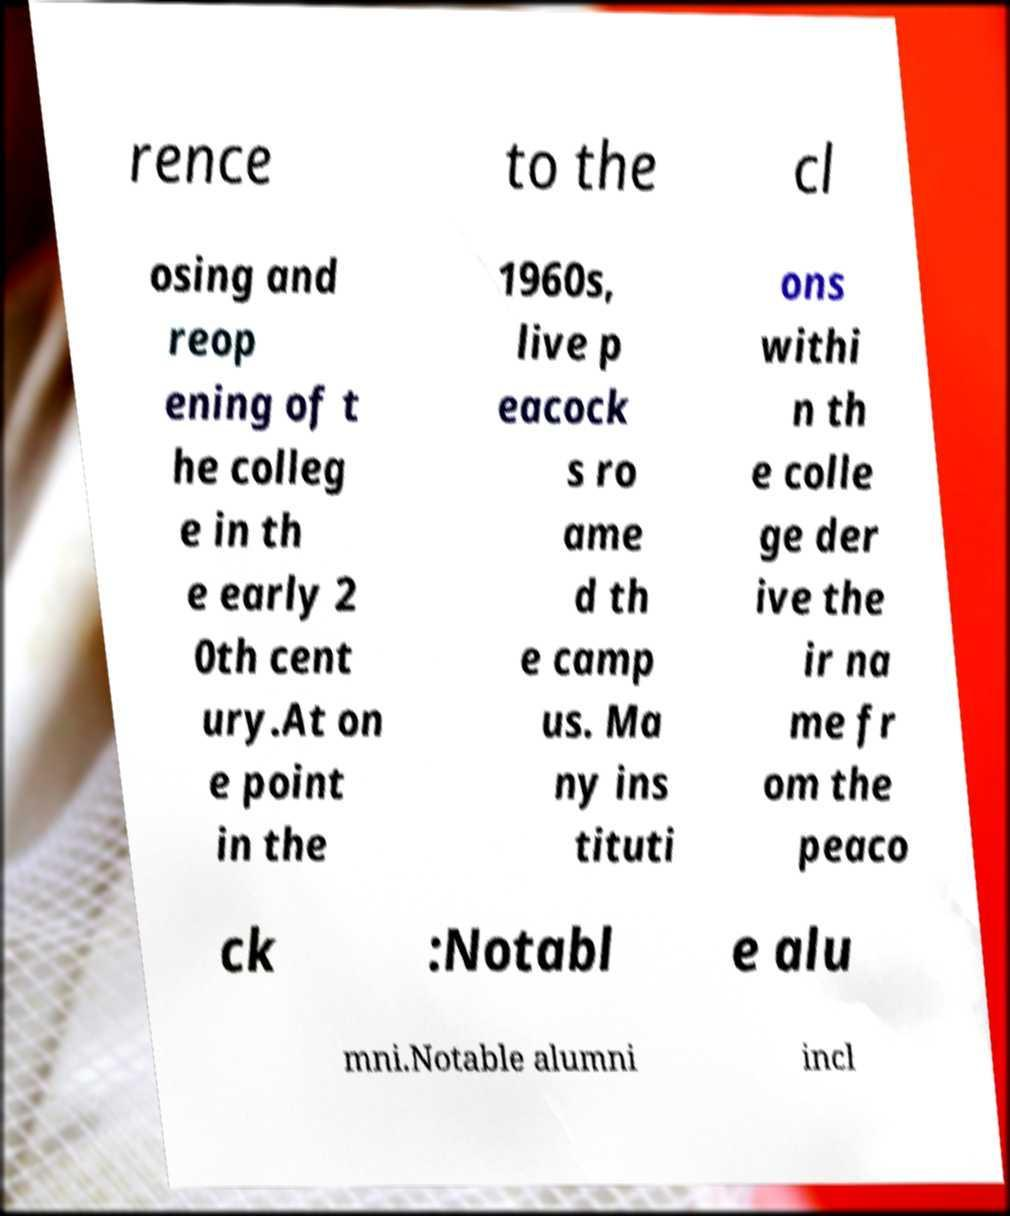Can you read and provide the text displayed in the image?This photo seems to have some interesting text. Can you extract and type it out for me? rence to the cl osing and reop ening of t he colleg e in th e early 2 0th cent ury.At on e point in the 1960s, live p eacock s ro ame d th e camp us. Ma ny ins tituti ons withi n th e colle ge der ive the ir na me fr om the peaco ck :Notabl e alu mni.Notable alumni incl 